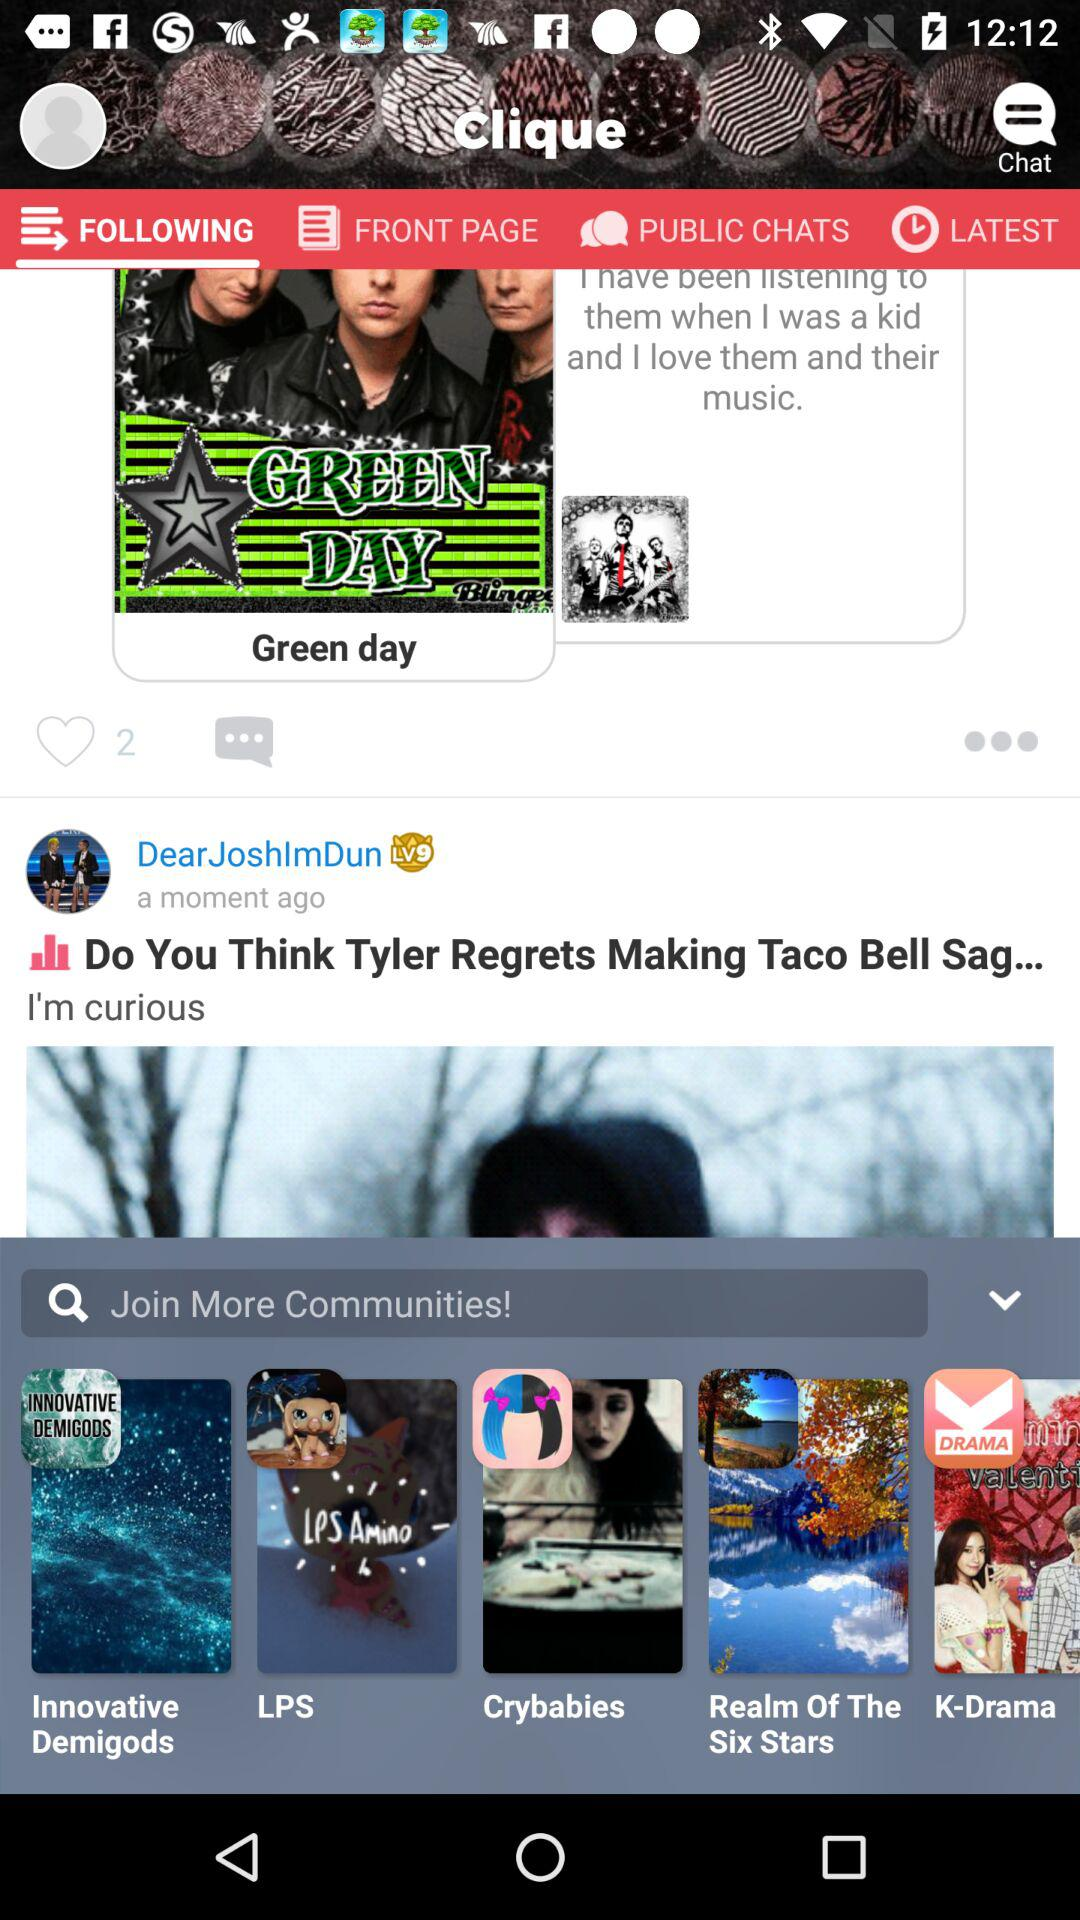How many likes are there? There are 2 likes. 